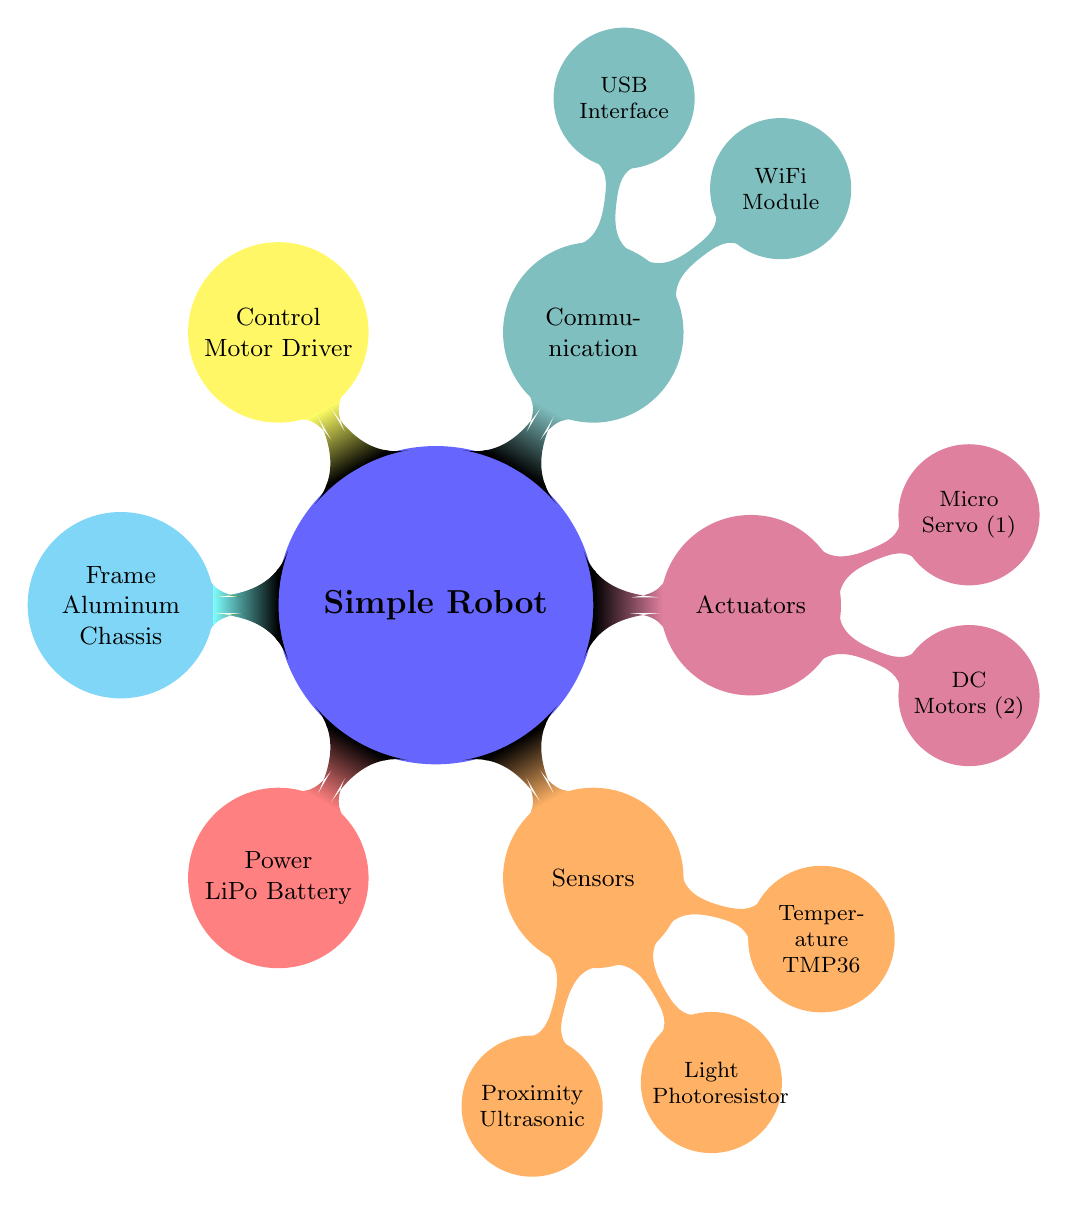What is the central unit of the robot? The central processing unit is represented in the diagram by the node connected to the "Simple Robot" central node, labeled as "Raspberry Pi".
Answer: Raspberry Pi How many motors does the robot have? The diagram indicates the number of motors in the "Actuators" section, specifically stating there are "2" DC Motors.
Answer: 2 Which type of battery is used for power? The power source in the diagram is described as "Lithium Polymer Battery", which is directly connected to the "Simple Robot" central node.
Answer: Lithium Polymer Battery What type of temperature sensor is mentioned? To find the temperature sensor, the reasoning involves looking at the "Sensors" section and identifying the specific sensor listed, which is "TMP36".
Answer: TMP36 What are the two methods of communication shown? The diagram highlights two communication methods under the "Communication" section: "WiFi Module" and "USB Interface". By evaluating this section, we find these two distinct methods connected to the central node.
Answer: WiFi Module, USB Interface What component controls the motors? The "Control Mechanism" node in the diagram explicitly states that a "Motor Driver Board" is used to control the motors, which can be directly referenced under that label.
Answer: Motor Driver Board How many types of actuators are listed? In the "Actuators" section, there are two distinct types mentioned: DC Motors and Micro Servo Motor. By counting these nodes, we establish there are "2" types.
Answer: 2 What is the frame material of the robot? The "Frame" node in the diagram indicates that the material used for the robot's structure is "Aluminum Chassis", which can be identified as a distinct element connected to the central concept.
Answer: Aluminum Chassis What is the total number of sensors listed? The "Sensors" section includes three different sensors: Ultrasonic, Photoresistor, and TMP36. By counting these, we find a total of "3" sensors represented in the diagram.
Answer: 3 What is the type of motor used? The "Actuators" node details the type of motors as "DC Motor", which is specifically noted under the motor type in the "Actuators" section of the diagram.
Answer: DC Motor 